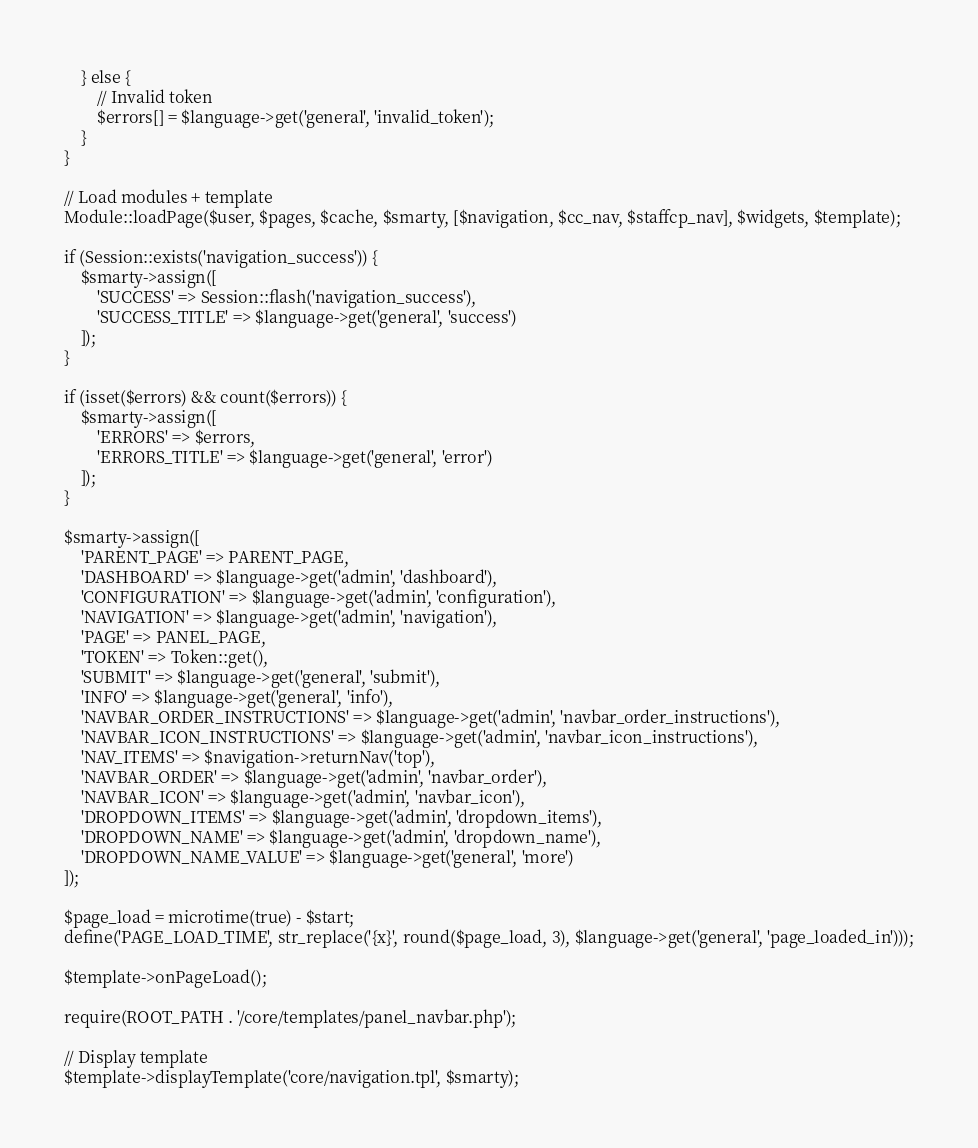Convert code to text. <code><loc_0><loc_0><loc_500><loc_500><_PHP_>    } else {
        // Invalid token
        $errors[] = $language->get('general', 'invalid_token');
    }
}

// Load modules + template
Module::loadPage($user, $pages, $cache, $smarty, [$navigation, $cc_nav, $staffcp_nav], $widgets, $template);

if (Session::exists('navigation_success')) {
    $smarty->assign([
        'SUCCESS' => Session::flash('navigation_success'),
        'SUCCESS_TITLE' => $language->get('general', 'success')
    ]);
}

if (isset($errors) && count($errors)) {
    $smarty->assign([
        'ERRORS' => $errors,
        'ERRORS_TITLE' => $language->get('general', 'error')
    ]);
}

$smarty->assign([
    'PARENT_PAGE' => PARENT_PAGE,
    'DASHBOARD' => $language->get('admin', 'dashboard'),
    'CONFIGURATION' => $language->get('admin', 'configuration'),
    'NAVIGATION' => $language->get('admin', 'navigation'),
    'PAGE' => PANEL_PAGE,
    'TOKEN' => Token::get(),
    'SUBMIT' => $language->get('general', 'submit'),
    'INFO' => $language->get('general', 'info'),
    'NAVBAR_ORDER_INSTRUCTIONS' => $language->get('admin', 'navbar_order_instructions'),
    'NAVBAR_ICON_INSTRUCTIONS' => $language->get('admin', 'navbar_icon_instructions'),
    'NAV_ITEMS' => $navigation->returnNav('top'),
    'NAVBAR_ORDER' => $language->get('admin', 'navbar_order'),
    'NAVBAR_ICON' => $language->get('admin', 'navbar_icon'),
    'DROPDOWN_ITEMS' => $language->get('admin', 'dropdown_items'),
    'DROPDOWN_NAME' => $language->get('admin', 'dropdown_name'),
    'DROPDOWN_NAME_VALUE' => $language->get('general', 'more')
]);

$page_load = microtime(true) - $start;
define('PAGE_LOAD_TIME', str_replace('{x}', round($page_load, 3), $language->get('general', 'page_loaded_in')));

$template->onPageLoad();

require(ROOT_PATH . '/core/templates/panel_navbar.php');

// Display template
$template->displayTemplate('core/navigation.tpl', $smarty);
</code> 